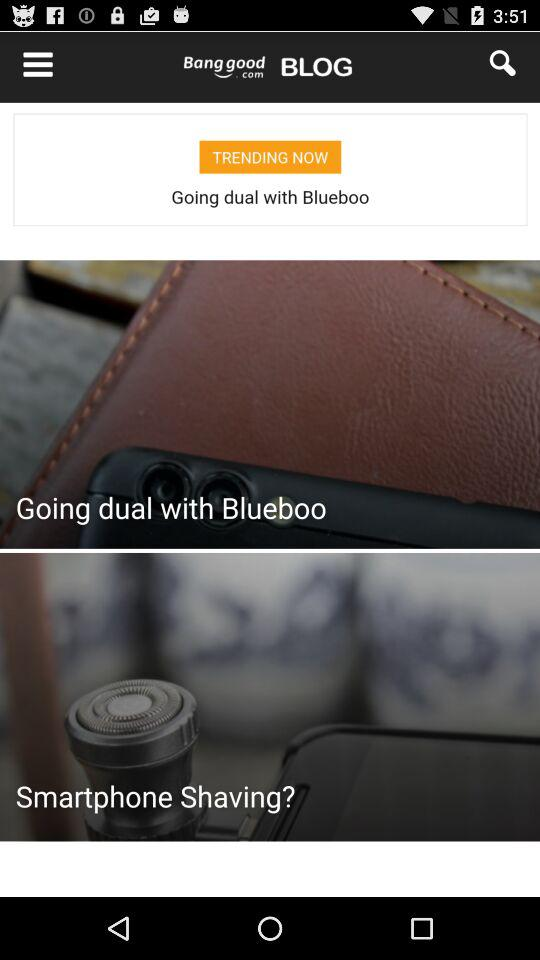How much is the discount for this product?
Answer the question using a single word or phrase. 41% 